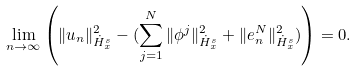Convert formula to latex. <formula><loc_0><loc_0><loc_500><loc_500>\lim _ { n \to \infty } \left ( \| u _ { n } \| ^ { 2 } _ { \dot { H } ^ { s } _ { x } } - ( \sum _ { j = 1 } ^ { N } \| \phi ^ { j } \| ^ { 2 } _ { \dot { H } ^ { s } _ { x } } + \| e _ { n } ^ { N } \| ^ { 2 } _ { \dot { H } ^ { s } _ { x } } ) \right ) = 0 .</formula> 